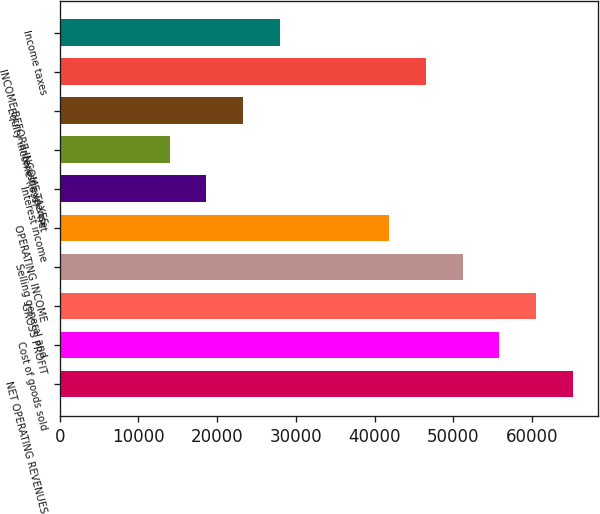Convert chart to OTSL. <chart><loc_0><loc_0><loc_500><loc_500><bar_chart><fcel>NET OPERATING REVENUES<fcel>Cost of goods sold<fcel>GROSS PROFIT<fcel>Selling general and<fcel>OPERATING INCOME<fcel>Interest income<fcel>Interest expense<fcel>Equity income (loss) - net<fcel>INCOME BEFORE INCOME TAXES<fcel>Income taxes<nl><fcel>65158.1<fcel>55850<fcel>60504<fcel>51196<fcel>41888<fcel>18617.9<fcel>13963.9<fcel>23271.9<fcel>46542<fcel>27925.9<nl></chart> 